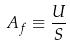Convert formula to latex. <formula><loc_0><loc_0><loc_500><loc_500>A _ { f } \equiv \frac { U } { S }</formula> 